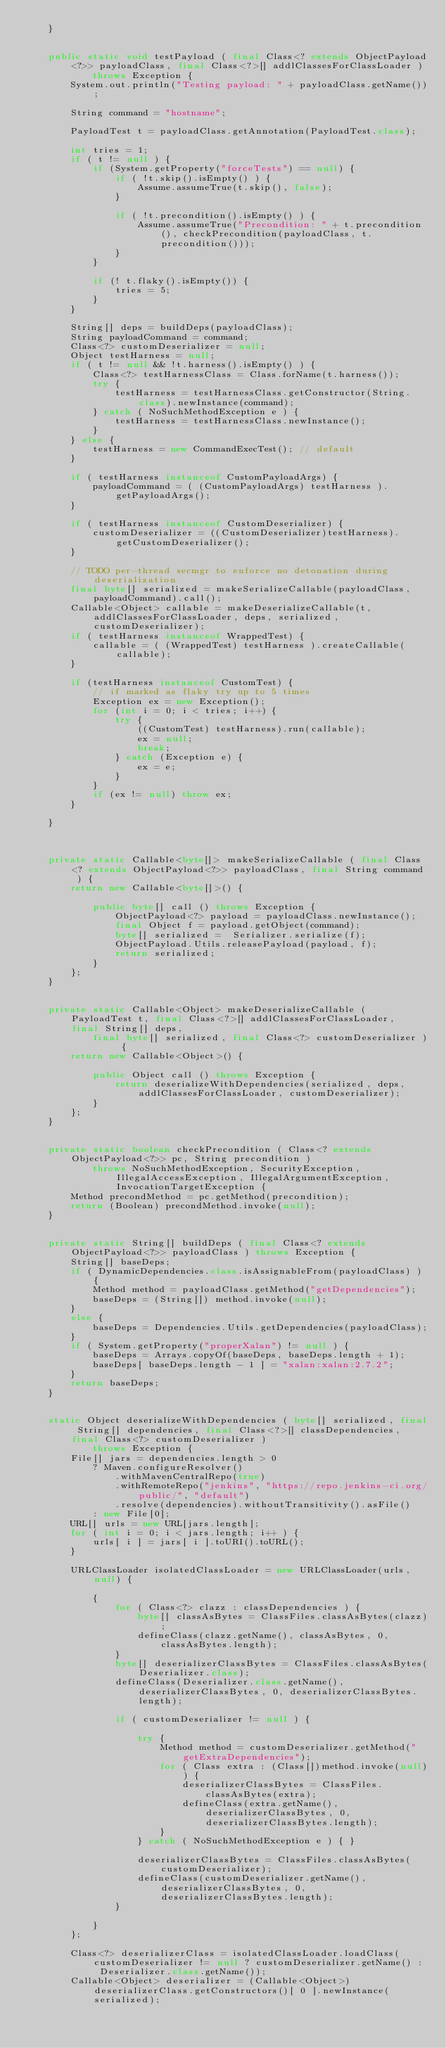<code> <loc_0><loc_0><loc_500><loc_500><_Java_>    }


    public static void testPayload ( final Class<? extends ObjectPayload<?>> payloadClass, final Class<?>[] addlClassesForClassLoader )
            throws Exception {
        System.out.println("Testing payload: " + payloadClass.getName());

        String command = "hostname";

        PayloadTest t = payloadClass.getAnnotation(PayloadTest.class);

        int tries = 1;
        if ( t != null ) {
            if (System.getProperty("forceTests") == null) {
                if ( !t.skip().isEmpty() ) {
                    Assume.assumeTrue(t.skip(), false);
                }

                if ( !t.precondition().isEmpty() ) {
                    Assume.assumeTrue("Precondition: " + t.precondition(), checkPrecondition(payloadClass, t.precondition()));
                }
            }

            if (! t.flaky().isEmpty()) {
                tries = 5;
            }
        }

        String[] deps = buildDeps(payloadClass);
        String payloadCommand = command;
        Class<?> customDeserializer = null;
        Object testHarness = null;
        if ( t != null && !t.harness().isEmpty() ) {
            Class<?> testHarnessClass = Class.forName(t.harness());
            try {
                testHarness = testHarnessClass.getConstructor(String.class).newInstance(command);
            } catch ( NoSuchMethodException e ) {
                testHarness = testHarnessClass.newInstance();
            }
        } else {
            testHarness = new CommandExecTest(); // default
        }

        if ( testHarness instanceof CustomPayloadArgs) {
            payloadCommand = ( (CustomPayloadArgs) testHarness ).getPayloadArgs();
        }

        if ( testHarness instanceof CustomDeserializer) {
            customDeserializer = ((CustomDeserializer)testHarness).getCustomDeserializer();
        }

        // TODO per-thread secmgr to enforce no detonation during deserialization
        final byte[] serialized = makeSerializeCallable(payloadClass, payloadCommand).call();
        Callable<Object> callable = makeDeserializeCallable(t, addlClassesForClassLoader, deps, serialized, customDeserializer);
        if ( testHarness instanceof WrappedTest) {
            callable = ( (WrappedTest) testHarness ).createCallable(callable);
        }

        if (testHarness instanceof CustomTest) {
            // if marked as flaky try up to 5 times
            Exception ex = new Exception();
            for (int i = 0; i < tries; i++) {
                try {
                    ((CustomTest) testHarness).run(callable);
                    ex = null;
                    break;
                } catch (Exception e) {
                    ex = e;
                }
            }
            if (ex != null) throw ex;
        }

    }



    private static Callable<byte[]> makeSerializeCallable ( final Class<? extends ObjectPayload<?>> payloadClass, final String command ) {
        return new Callable<byte[]>() {

            public byte[] call () throws Exception {
                ObjectPayload<?> payload = payloadClass.newInstance();
                final Object f = payload.getObject(command);
                byte[] serialized =  Serializer.serialize(f);
                ObjectPayload.Utils.releasePayload(payload, f);
                return serialized;
            }
        };
    }


    private static Callable<Object> makeDeserializeCallable ( PayloadTest t, final Class<?>[] addlClassesForClassLoader, final String[] deps,
            final byte[] serialized, final Class<?> customDeserializer ) {
        return new Callable<Object>() {

            public Object call () throws Exception {
                return deserializeWithDependencies(serialized, deps, addlClassesForClassLoader, customDeserializer);
            }
        };
    }


    private static boolean checkPrecondition ( Class<? extends ObjectPayload<?>> pc, String precondition )
            throws NoSuchMethodException, SecurityException, IllegalAccessException, IllegalArgumentException, InvocationTargetException {
        Method precondMethod = pc.getMethod(precondition);
        return (Boolean) precondMethod.invoke(null);
    }


    private static String[] buildDeps ( final Class<? extends ObjectPayload<?>> payloadClass ) throws Exception {
        String[] baseDeps;
        if ( DynamicDependencies.class.isAssignableFrom(payloadClass) ) {
            Method method = payloadClass.getMethod("getDependencies");
            baseDeps = (String[]) method.invoke(null);
        }
        else {
            baseDeps = Dependencies.Utils.getDependencies(payloadClass);
        }
        if ( System.getProperty("properXalan") != null ) {
            baseDeps = Arrays.copyOf(baseDeps, baseDeps.length + 1);
            baseDeps[ baseDeps.length - 1 ] = "xalan:xalan:2.7.2";
        }
        return baseDeps;
    }


    static Object deserializeWithDependencies ( byte[] serialized, final String[] dependencies, final Class<?>[] classDependencies, final Class<?> customDeserializer )
            throws Exception {
        File[] jars = dependencies.length > 0
            ? Maven.configureResolver()
                .withMavenCentralRepo(true)
                .withRemoteRepo("jenkins", "https://repo.jenkins-ci.org/public/", "default")
                .resolve(dependencies).withoutTransitivity().asFile()
            : new File[0];
        URL[] urls = new URL[jars.length];
        for ( int i = 0; i < jars.length; i++ ) {
            urls[ i ] = jars[ i ].toURI().toURL();
        }

        URLClassLoader isolatedClassLoader = new URLClassLoader(urls, null) {

            {
                for ( Class<?> clazz : classDependencies ) {
                    byte[] classAsBytes = ClassFiles.classAsBytes(clazz);
                    defineClass(clazz.getName(), classAsBytes, 0, classAsBytes.length);
                }
                byte[] deserializerClassBytes = ClassFiles.classAsBytes(Deserializer.class);
                defineClass(Deserializer.class.getName(), deserializerClassBytes, 0, deserializerClassBytes.length);

                if ( customDeserializer != null ) {

                    try {
                        Method method = customDeserializer.getMethod("getExtraDependencies");
                        for ( Class extra : (Class[])method.invoke(null)) {
                            deserializerClassBytes = ClassFiles.classAsBytes(extra);
                            defineClass(extra.getName(), deserializerClassBytes, 0, deserializerClassBytes.length);
                        }
                    } catch ( NoSuchMethodException e ) { }

                    deserializerClassBytes = ClassFiles.classAsBytes(customDeserializer);
                    defineClass(customDeserializer.getName(), deserializerClassBytes, 0, deserializerClassBytes.length);
                }

            }
        };

        Class<?> deserializerClass = isolatedClassLoader.loadClass(customDeserializer != null ? customDeserializer.getName() : Deserializer.class.getName());
        Callable<Object> deserializer = (Callable<Object>) deserializerClass.getConstructors()[ 0 ].newInstance(serialized);
</code> 